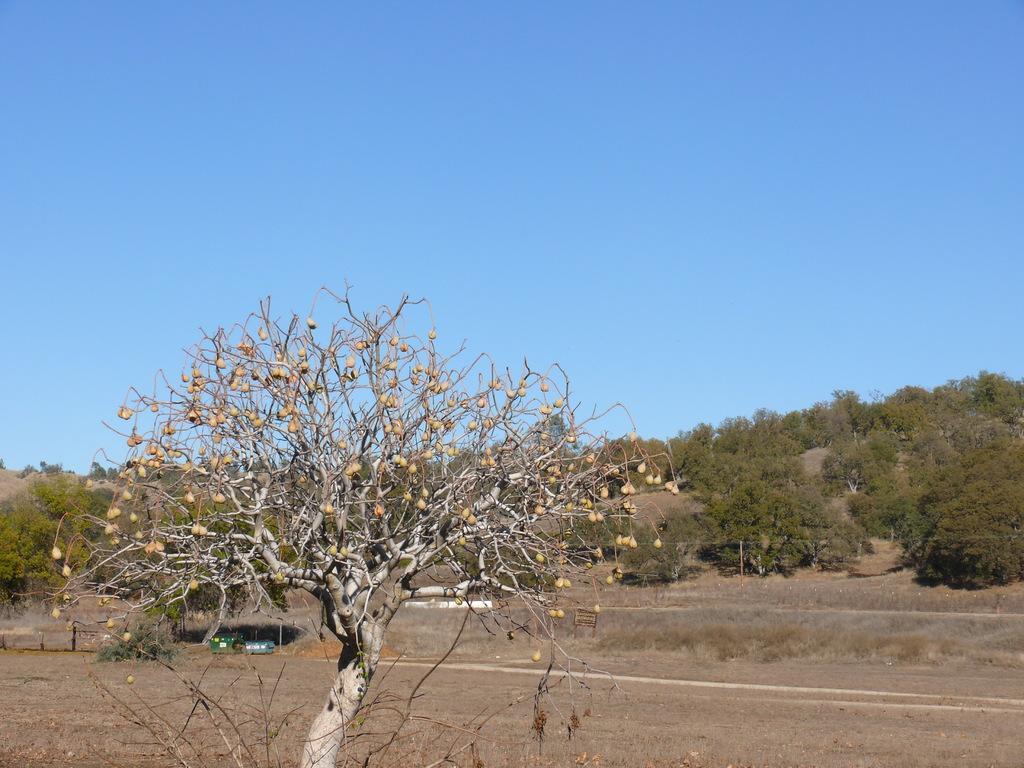Describe this image in one or two sentences. In the picture we can see a tree and behind it, we can see the surface and far away from it we can see the trees and the sky. 